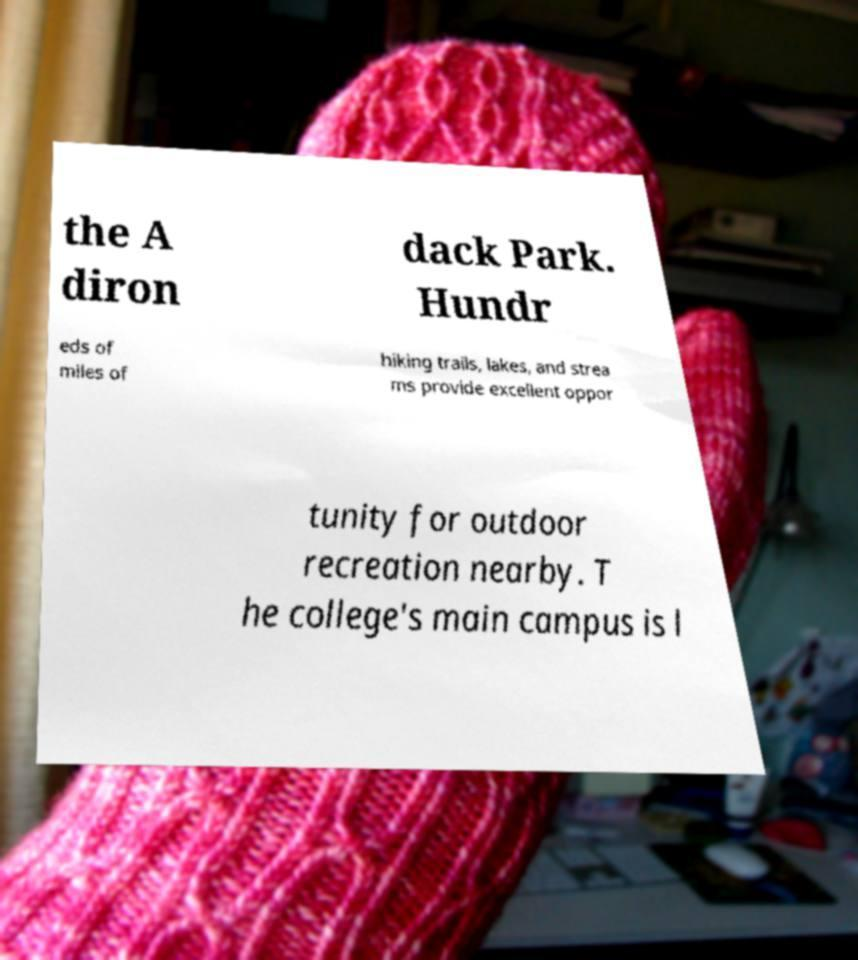What messages or text are displayed in this image? I need them in a readable, typed format. the A diron dack Park. Hundr eds of miles of hiking trails, lakes, and strea ms provide excellent oppor tunity for outdoor recreation nearby. T he college's main campus is l 